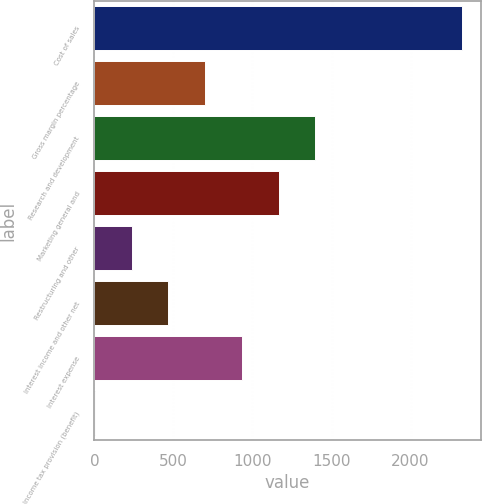<chart> <loc_0><loc_0><loc_500><loc_500><bar_chart><fcel>Cost of sales<fcel>Gross margin percentage<fcel>Research and development<fcel>Marketing general and<fcel>Restructuring and other<fcel>Interest income and other net<fcel>Interest expense<fcel>Income tax provision (benefit)<nl><fcel>2327<fcel>700.2<fcel>1397.4<fcel>1165<fcel>235.4<fcel>467.8<fcel>932.6<fcel>3<nl></chart> 